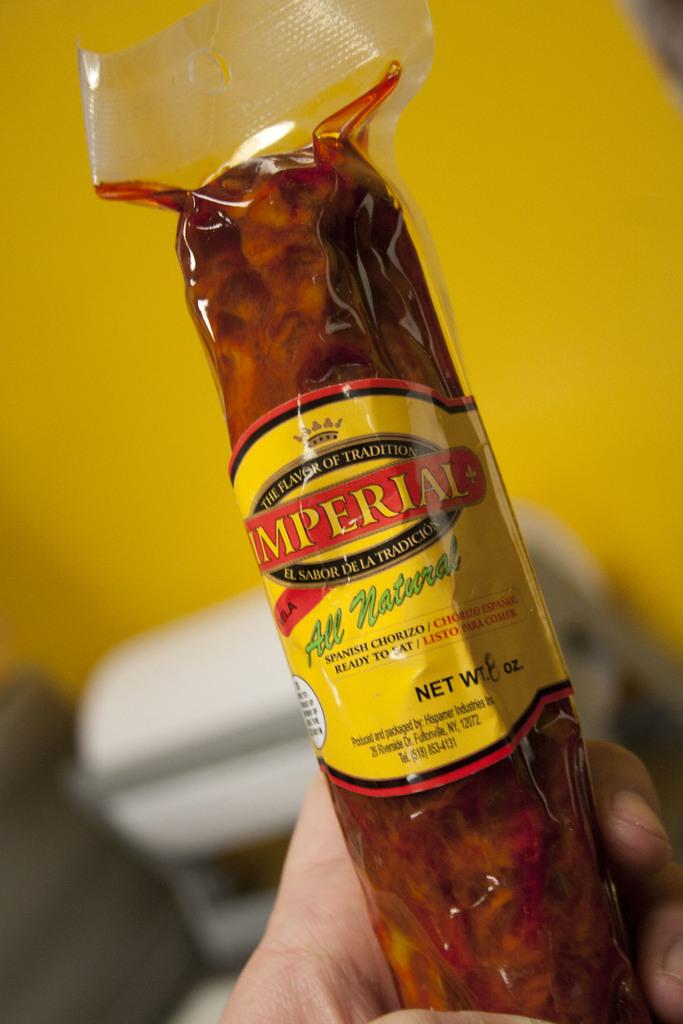What's the weight of this?
Your answer should be compact. 8 oz. What is the brand of sausage written on the package?
Give a very brief answer. Imperial. 